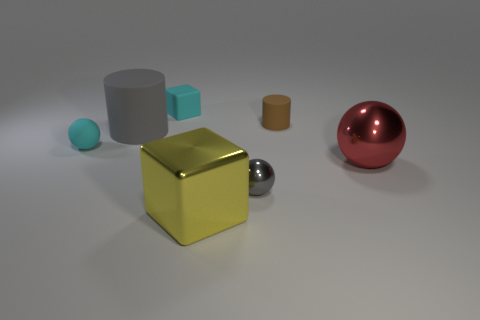Add 2 big red things. How many objects exist? 9 Subtract all spheres. How many objects are left? 4 Add 7 matte blocks. How many matte blocks exist? 8 Subtract 0 blue blocks. How many objects are left? 7 Subtract all tiny objects. Subtract all big gray matte balls. How many objects are left? 3 Add 4 big red objects. How many big red objects are left? 5 